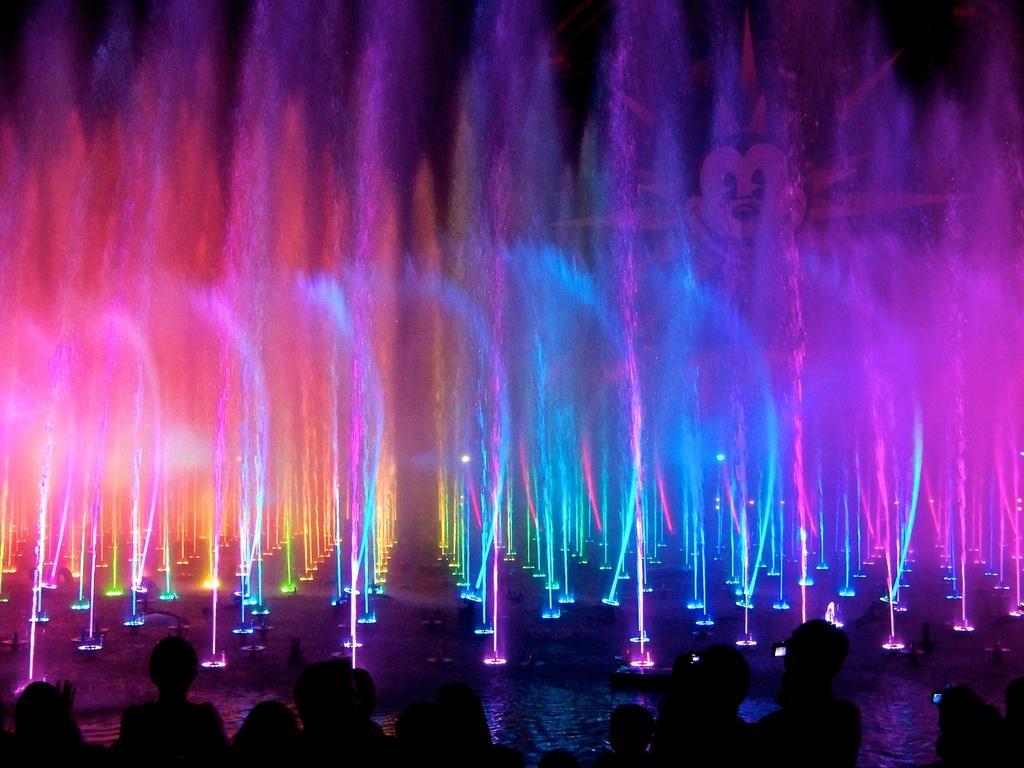Could you give a brief overview of what you see in this image? In this image, we can see light show with water fountains. At the bottom, we can see few people. Here we can see a mickey mouse. 